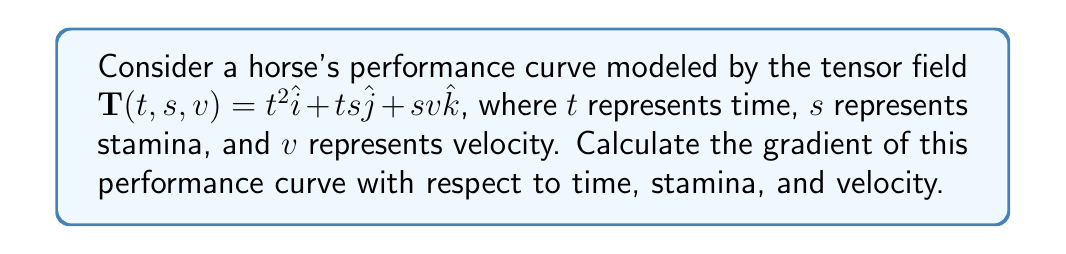What is the answer to this math problem? To determine the gradient of the horse's performance curve, we need to calculate the partial derivatives of the tensor field $\mathbf{T}(t, s, v)$ with respect to each variable.

Step 1: Calculate the partial derivative with respect to time $(t)$:
$$\frac{\partial \mathbf{T}}{\partial t} = \frac{\partial}{\partial t}(t^2\hat{i} + ts\hat{j} + sv\hat{k}) = 2t\hat{i} + s\hat{j}$$

Step 2: Calculate the partial derivative with respect to stamina $(s)$:
$$\frac{\partial \mathbf{T}}{\partial s} = \frac{\partial}{\partial s}(t^2\hat{i} + ts\hat{j} + sv\hat{k}) = t\hat{j} + v\hat{k}$$

Step 3: Calculate the partial derivative with respect to velocity $(v)$:
$$\frac{\partial \mathbf{T}}{\partial v} = \frac{\partial}{\partial v}(t^2\hat{i} + ts\hat{j} + sv\hat{k}) = s\hat{k}$$

Step 4: Combine the partial derivatives to form the gradient:
$$\nabla \mathbf{T} = \left(\frac{\partial \mathbf{T}}{\partial t}, \frac{\partial \mathbf{T}}{\partial s}, \frac{\partial \mathbf{T}}{\partial v}\right) = (2t\hat{i} + s\hat{j}, t\hat{j} + v\hat{k}, s\hat{k})$$
Answer: $\nabla \mathbf{T} = (2t\hat{i} + s\hat{j}, t\hat{j} + v\hat{k}, s\hat{k})$ 